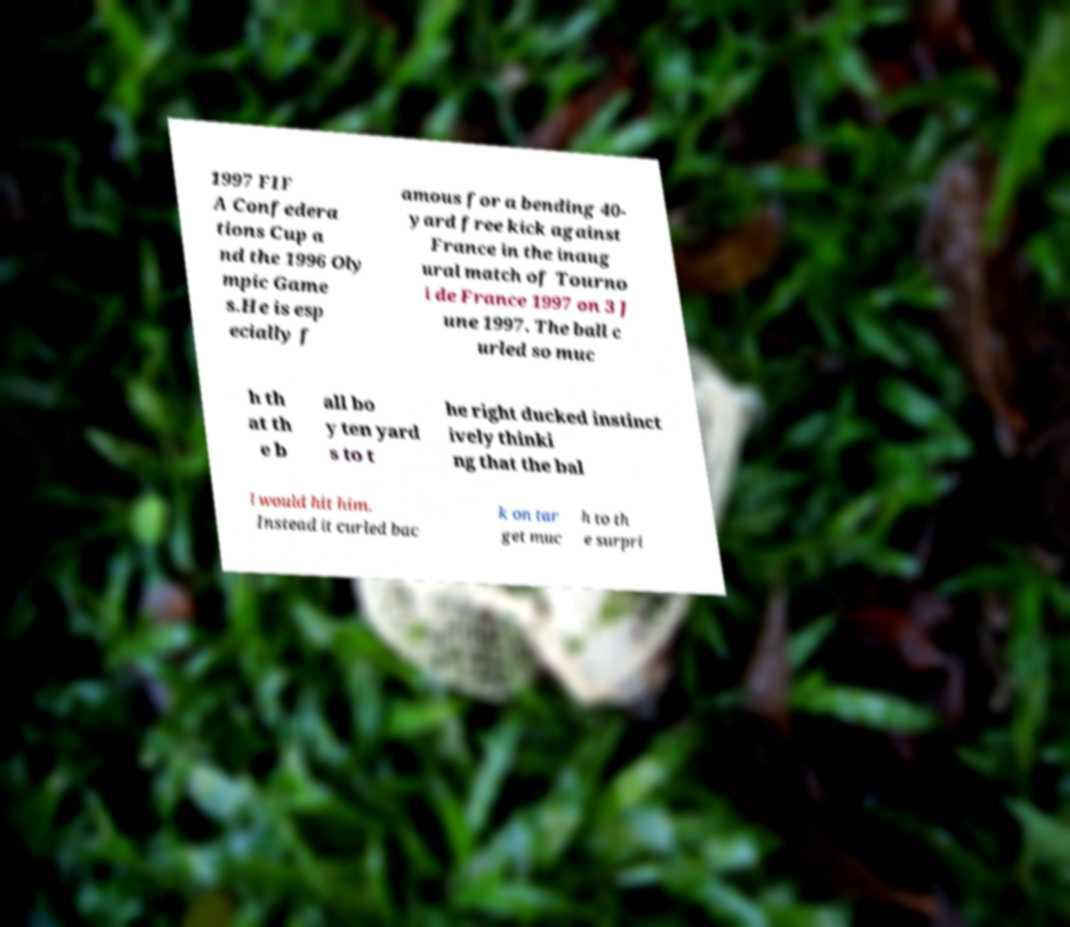Could you assist in decoding the text presented in this image and type it out clearly? 1997 FIF A Confedera tions Cup a nd the 1996 Oly mpic Game s.He is esp ecially f amous for a bending 40- yard free kick against France in the inaug ural match of Tourno i de France 1997 on 3 J une 1997. The ball c urled so muc h th at th e b all bo y ten yard s to t he right ducked instinct ively thinki ng that the bal l would hit him. Instead it curled bac k on tar get muc h to th e surpri 